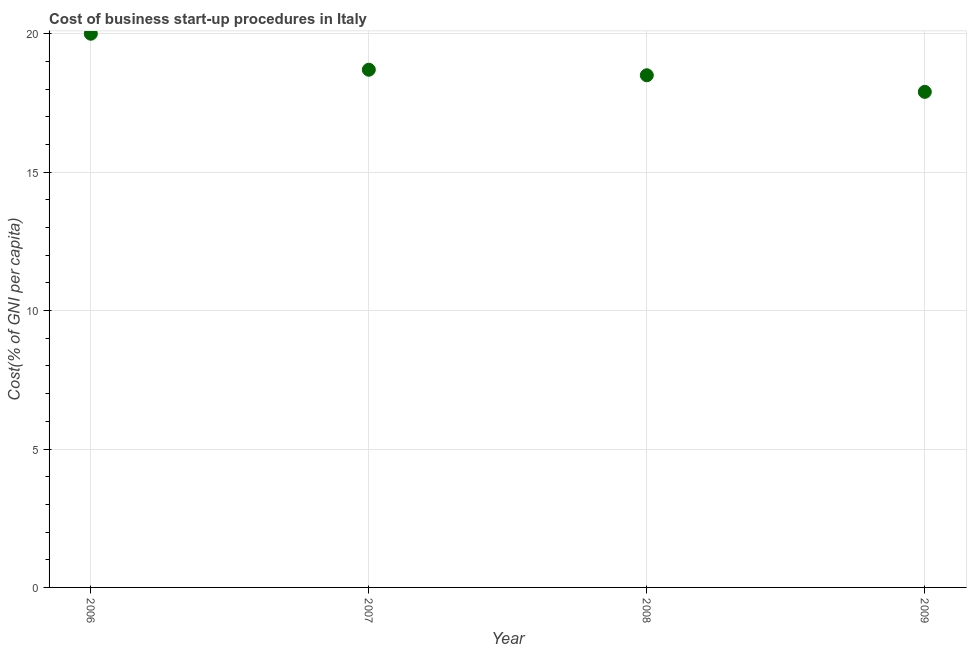What is the cost of business startup procedures in 2008?
Give a very brief answer. 18.5. Across all years, what is the minimum cost of business startup procedures?
Offer a very short reply. 17.9. In which year was the cost of business startup procedures maximum?
Give a very brief answer. 2006. In which year was the cost of business startup procedures minimum?
Offer a terse response. 2009. What is the sum of the cost of business startup procedures?
Offer a very short reply. 75.1. What is the difference between the cost of business startup procedures in 2007 and 2009?
Offer a terse response. 0.8. What is the average cost of business startup procedures per year?
Make the answer very short. 18.77. In how many years, is the cost of business startup procedures greater than 5 %?
Provide a succinct answer. 4. What is the ratio of the cost of business startup procedures in 2008 to that in 2009?
Make the answer very short. 1.03. Is the cost of business startup procedures in 2006 less than that in 2008?
Provide a succinct answer. No. Is the difference between the cost of business startup procedures in 2007 and 2008 greater than the difference between any two years?
Provide a succinct answer. No. What is the difference between the highest and the second highest cost of business startup procedures?
Keep it short and to the point. 1.3. What is the difference between the highest and the lowest cost of business startup procedures?
Provide a succinct answer. 2.1. In how many years, is the cost of business startup procedures greater than the average cost of business startup procedures taken over all years?
Keep it short and to the point. 1. How many dotlines are there?
Ensure brevity in your answer.  1. What is the difference between two consecutive major ticks on the Y-axis?
Your response must be concise. 5. Are the values on the major ticks of Y-axis written in scientific E-notation?
Your answer should be compact. No. Does the graph contain any zero values?
Keep it short and to the point. No. Does the graph contain grids?
Your answer should be very brief. Yes. What is the title of the graph?
Your response must be concise. Cost of business start-up procedures in Italy. What is the label or title of the X-axis?
Offer a terse response. Year. What is the label or title of the Y-axis?
Provide a short and direct response. Cost(% of GNI per capita). What is the difference between the Cost(% of GNI per capita) in 2006 and 2008?
Give a very brief answer. 1.5. What is the difference between the Cost(% of GNI per capita) in 2007 and 2008?
Ensure brevity in your answer.  0.2. What is the ratio of the Cost(% of GNI per capita) in 2006 to that in 2007?
Give a very brief answer. 1.07. What is the ratio of the Cost(% of GNI per capita) in 2006 to that in 2008?
Provide a succinct answer. 1.08. What is the ratio of the Cost(% of GNI per capita) in 2006 to that in 2009?
Make the answer very short. 1.12. What is the ratio of the Cost(% of GNI per capita) in 2007 to that in 2009?
Your response must be concise. 1.04. What is the ratio of the Cost(% of GNI per capita) in 2008 to that in 2009?
Provide a succinct answer. 1.03. 